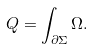Convert formula to latex. <formula><loc_0><loc_0><loc_500><loc_500>Q = \int _ { \partial \Sigma } \Omega .</formula> 